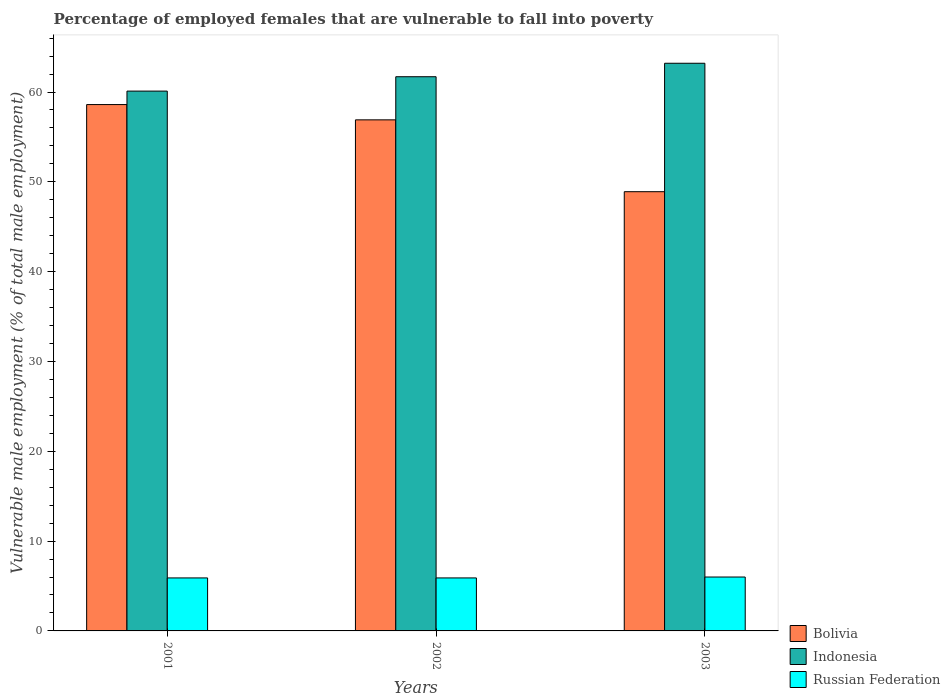How many different coloured bars are there?
Your answer should be very brief. 3. How many groups of bars are there?
Your response must be concise. 3. Are the number of bars per tick equal to the number of legend labels?
Offer a terse response. Yes. Are the number of bars on each tick of the X-axis equal?
Provide a succinct answer. Yes. What is the label of the 3rd group of bars from the left?
Your answer should be compact. 2003. What is the percentage of employed females who are vulnerable to fall into poverty in Russian Federation in 2003?
Give a very brief answer. 6. Across all years, what is the maximum percentage of employed females who are vulnerable to fall into poverty in Bolivia?
Make the answer very short. 58.6. Across all years, what is the minimum percentage of employed females who are vulnerable to fall into poverty in Bolivia?
Ensure brevity in your answer.  48.9. What is the total percentage of employed females who are vulnerable to fall into poverty in Russian Federation in the graph?
Make the answer very short. 17.8. What is the difference between the percentage of employed females who are vulnerable to fall into poverty in Indonesia in 2003 and the percentage of employed females who are vulnerable to fall into poverty in Bolivia in 2002?
Keep it short and to the point. 6.3. What is the average percentage of employed females who are vulnerable to fall into poverty in Russian Federation per year?
Make the answer very short. 5.93. In the year 2003, what is the difference between the percentage of employed females who are vulnerable to fall into poverty in Russian Federation and percentage of employed females who are vulnerable to fall into poverty in Bolivia?
Give a very brief answer. -42.9. In how many years, is the percentage of employed females who are vulnerable to fall into poverty in Russian Federation greater than 58 %?
Make the answer very short. 0. What is the ratio of the percentage of employed females who are vulnerable to fall into poverty in Indonesia in 2002 to that in 2003?
Offer a terse response. 0.98. Is the difference between the percentage of employed females who are vulnerable to fall into poverty in Russian Federation in 2002 and 2003 greater than the difference between the percentage of employed females who are vulnerable to fall into poverty in Bolivia in 2002 and 2003?
Provide a short and direct response. No. What is the difference between the highest and the lowest percentage of employed females who are vulnerable to fall into poverty in Russian Federation?
Keep it short and to the point. 0.1. In how many years, is the percentage of employed females who are vulnerable to fall into poverty in Bolivia greater than the average percentage of employed females who are vulnerable to fall into poverty in Bolivia taken over all years?
Your answer should be compact. 2. How many bars are there?
Your response must be concise. 9. What is the difference between two consecutive major ticks on the Y-axis?
Your answer should be compact. 10. Are the values on the major ticks of Y-axis written in scientific E-notation?
Make the answer very short. No. What is the title of the graph?
Give a very brief answer. Percentage of employed females that are vulnerable to fall into poverty. What is the label or title of the Y-axis?
Keep it short and to the point. Vulnerable male employment (% of total male employment). What is the Vulnerable male employment (% of total male employment) in Bolivia in 2001?
Ensure brevity in your answer.  58.6. What is the Vulnerable male employment (% of total male employment) of Indonesia in 2001?
Provide a short and direct response. 60.1. What is the Vulnerable male employment (% of total male employment) in Russian Federation in 2001?
Your answer should be compact. 5.9. What is the Vulnerable male employment (% of total male employment) of Bolivia in 2002?
Make the answer very short. 56.9. What is the Vulnerable male employment (% of total male employment) in Indonesia in 2002?
Your answer should be compact. 61.7. What is the Vulnerable male employment (% of total male employment) of Russian Federation in 2002?
Your answer should be very brief. 5.9. What is the Vulnerable male employment (% of total male employment) in Bolivia in 2003?
Ensure brevity in your answer.  48.9. What is the Vulnerable male employment (% of total male employment) in Indonesia in 2003?
Offer a very short reply. 63.2. What is the Vulnerable male employment (% of total male employment) in Russian Federation in 2003?
Make the answer very short. 6. Across all years, what is the maximum Vulnerable male employment (% of total male employment) in Bolivia?
Provide a succinct answer. 58.6. Across all years, what is the maximum Vulnerable male employment (% of total male employment) in Indonesia?
Give a very brief answer. 63.2. Across all years, what is the maximum Vulnerable male employment (% of total male employment) in Russian Federation?
Offer a very short reply. 6. Across all years, what is the minimum Vulnerable male employment (% of total male employment) in Bolivia?
Make the answer very short. 48.9. Across all years, what is the minimum Vulnerable male employment (% of total male employment) of Indonesia?
Make the answer very short. 60.1. Across all years, what is the minimum Vulnerable male employment (% of total male employment) in Russian Federation?
Keep it short and to the point. 5.9. What is the total Vulnerable male employment (% of total male employment) in Bolivia in the graph?
Keep it short and to the point. 164.4. What is the total Vulnerable male employment (% of total male employment) of Indonesia in the graph?
Give a very brief answer. 185. What is the total Vulnerable male employment (% of total male employment) in Russian Federation in the graph?
Keep it short and to the point. 17.8. What is the difference between the Vulnerable male employment (% of total male employment) in Russian Federation in 2001 and that in 2002?
Offer a very short reply. 0. What is the difference between the Vulnerable male employment (% of total male employment) of Bolivia in 2002 and that in 2003?
Offer a very short reply. 8. What is the difference between the Vulnerable male employment (% of total male employment) of Indonesia in 2002 and that in 2003?
Provide a succinct answer. -1.5. What is the difference between the Vulnerable male employment (% of total male employment) in Russian Federation in 2002 and that in 2003?
Make the answer very short. -0.1. What is the difference between the Vulnerable male employment (% of total male employment) of Bolivia in 2001 and the Vulnerable male employment (% of total male employment) of Russian Federation in 2002?
Your response must be concise. 52.7. What is the difference between the Vulnerable male employment (% of total male employment) in Indonesia in 2001 and the Vulnerable male employment (% of total male employment) in Russian Federation in 2002?
Offer a very short reply. 54.2. What is the difference between the Vulnerable male employment (% of total male employment) in Bolivia in 2001 and the Vulnerable male employment (% of total male employment) in Indonesia in 2003?
Your answer should be very brief. -4.6. What is the difference between the Vulnerable male employment (% of total male employment) of Bolivia in 2001 and the Vulnerable male employment (% of total male employment) of Russian Federation in 2003?
Your answer should be compact. 52.6. What is the difference between the Vulnerable male employment (% of total male employment) in Indonesia in 2001 and the Vulnerable male employment (% of total male employment) in Russian Federation in 2003?
Make the answer very short. 54.1. What is the difference between the Vulnerable male employment (% of total male employment) of Bolivia in 2002 and the Vulnerable male employment (% of total male employment) of Indonesia in 2003?
Keep it short and to the point. -6.3. What is the difference between the Vulnerable male employment (% of total male employment) in Bolivia in 2002 and the Vulnerable male employment (% of total male employment) in Russian Federation in 2003?
Provide a succinct answer. 50.9. What is the difference between the Vulnerable male employment (% of total male employment) of Indonesia in 2002 and the Vulnerable male employment (% of total male employment) of Russian Federation in 2003?
Your response must be concise. 55.7. What is the average Vulnerable male employment (% of total male employment) in Bolivia per year?
Your answer should be compact. 54.8. What is the average Vulnerable male employment (% of total male employment) in Indonesia per year?
Your answer should be very brief. 61.67. What is the average Vulnerable male employment (% of total male employment) in Russian Federation per year?
Your response must be concise. 5.93. In the year 2001, what is the difference between the Vulnerable male employment (% of total male employment) of Bolivia and Vulnerable male employment (% of total male employment) of Indonesia?
Keep it short and to the point. -1.5. In the year 2001, what is the difference between the Vulnerable male employment (% of total male employment) in Bolivia and Vulnerable male employment (% of total male employment) in Russian Federation?
Offer a very short reply. 52.7. In the year 2001, what is the difference between the Vulnerable male employment (% of total male employment) in Indonesia and Vulnerable male employment (% of total male employment) in Russian Federation?
Provide a short and direct response. 54.2. In the year 2002, what is the difference between the Vulnerable male employment (% of total male employment) of Bolivia and Vulnerable male employment (% of total male employment) of Russian Federation?
Give a very brief answer. 51. In the year 2002, what is the difference between the Vulnerable male employment (% of total male employment) of Indonesia and Vulnerable male employment (% of total male employment) of Russian Federation?
Your answer should be compact. 55.8. In the year 2003, what is the difference between the Vulnerable male employment (% of total male employment) of Bolivia and Vulnerable male employment (% of total male employment) of Indonesia?
Offer a terse response. -14.3. In the year 2003, what is the difference between the Vulnerable male employment (% of total male employment) of Bolivia and Vulnerable male employment (% of total male employment) of Russian Federation?
Ensure brevity in your answer.  42.9. In the year 2003, what is the difference between the Vulnerable male employment (% of total male employment) of Indonesia and Vulnerable male employment (% of total male employment) of Russian Federation?
Provide a short and direct response. 57.2. What is the ratio of the Vulnerable male employment (% of total male employment) of Bolivia in 2001 to that in 2002?
Ensure brevity in your answer.  1.03. What is the ratio of the Vulnerable male employment (% of total male employment) of Indonesia in 2001 to that in 2002?
Keep it short and to the point. 0.97. What is the ratio of the Vulnerable male employment (% of total male employment) of Russian Federation in 2001 to that in 2002?
Provide a succinct answer. 1. What is the ratio of the Vulnerable male employment (% of total male employment) of Bolivia in 2001 to that in 2003?
Your answer should be compact. 1.2. What is the ratio of the Vulnerable male employment (% of total male employment) of Indonesia in 2001 to that in 2003?
Keep it short and to the point. 0.95. What is the ratio of the Vulnerable male employment (% of total male employment) of Russian Federation in 2001 to that in 2003?
Offer a very short reply. 0.98. What is the ratio of the Vulnerable male employment (% of total male employment) in Bolivia in 2002 to that in 2003?
Offer a very short reply. 1.16. What is the ratio of the Vulnerable male employment (% of total male employment) of Indonesia in 2002 to that in 2003?
Your answer should be compact. 0.98. What is the ratio of the Vulnerable male employment (% of total male employment) in Russian Federation in 2002 to that in 2003?
Keep it short and to the point. 0.98. What is the difference between the highest and the second highest Vulnerable male employment (% of total male employment) in Bolivia?
Make the answer very short. 1.7. What is the difference between the highest and the second highest Vulnerable male employment (% of total male employment) of Indonesia?
Offer a terse response. 1.5. What is the difference between the highest and the lowest Vulnerable male employment (% of total male employment) of Russian Federation?
Your answer should be very brief. 0.1. 